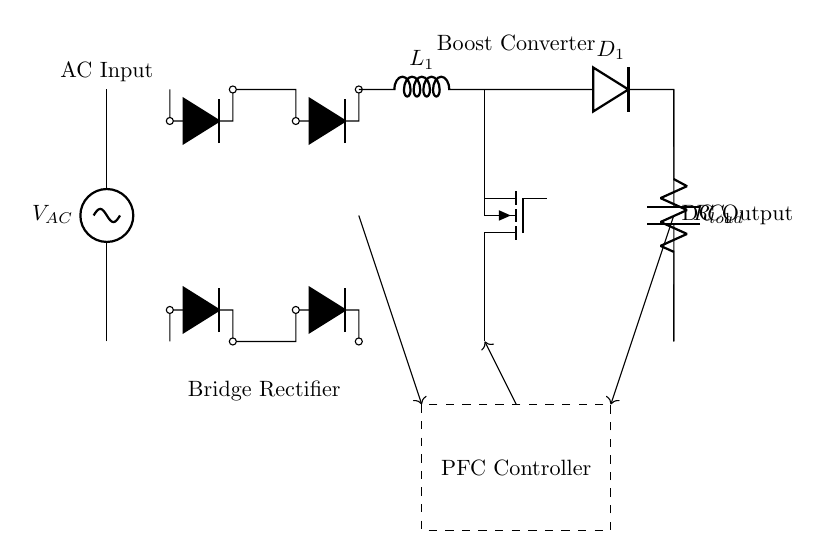What is the type of AC source used in the circuit? The circuit uses an AC voltage source, indicated by the symbol sV and labeled as VAC.
Answer: AC voltage What components are connected in series after the AC source? The series components include the bridge rectifier, which consists of four diodes connected in a specific arrangement. The output of the rectifier connects to a boost converter.
Answer: Bridge rectifier What is the main function of the PFC controller in this circuit? The PFC (Power Factor Correction) controller regulates the input current drawn by the circuit to improve the power factor. This ensures efficient power usage and minimizes reactive power.
Answer: Improve power factor How many diodes are used in the bridge rectifier? There are four diodes used in the bridge rectifier, which are indicated by the D* symbols in the circuit diagram.
Answer: Four diodes What is the role of the inductor labeled L1 in the boost converter? The inductor L1 temporarily stores energy during the on phase of the boost converter and releases it to increase the voltage during the off phase, thus contributing to voltage regulation.
Answer: Energy storage and voltage boost What type of load is represented in the circuit? The load represented in the circuit is a resistive load, as indicated by the R with a subscript load, suggesting it dissipates power in the form of heat.
Answer: Resistor What is the output voltage type after the boost converter? The output voltage type after the boost converter is directly indicated as DC voltage, as the boost converter's purpose is to convert the rectified AC to DC.
Answer: DC Output 